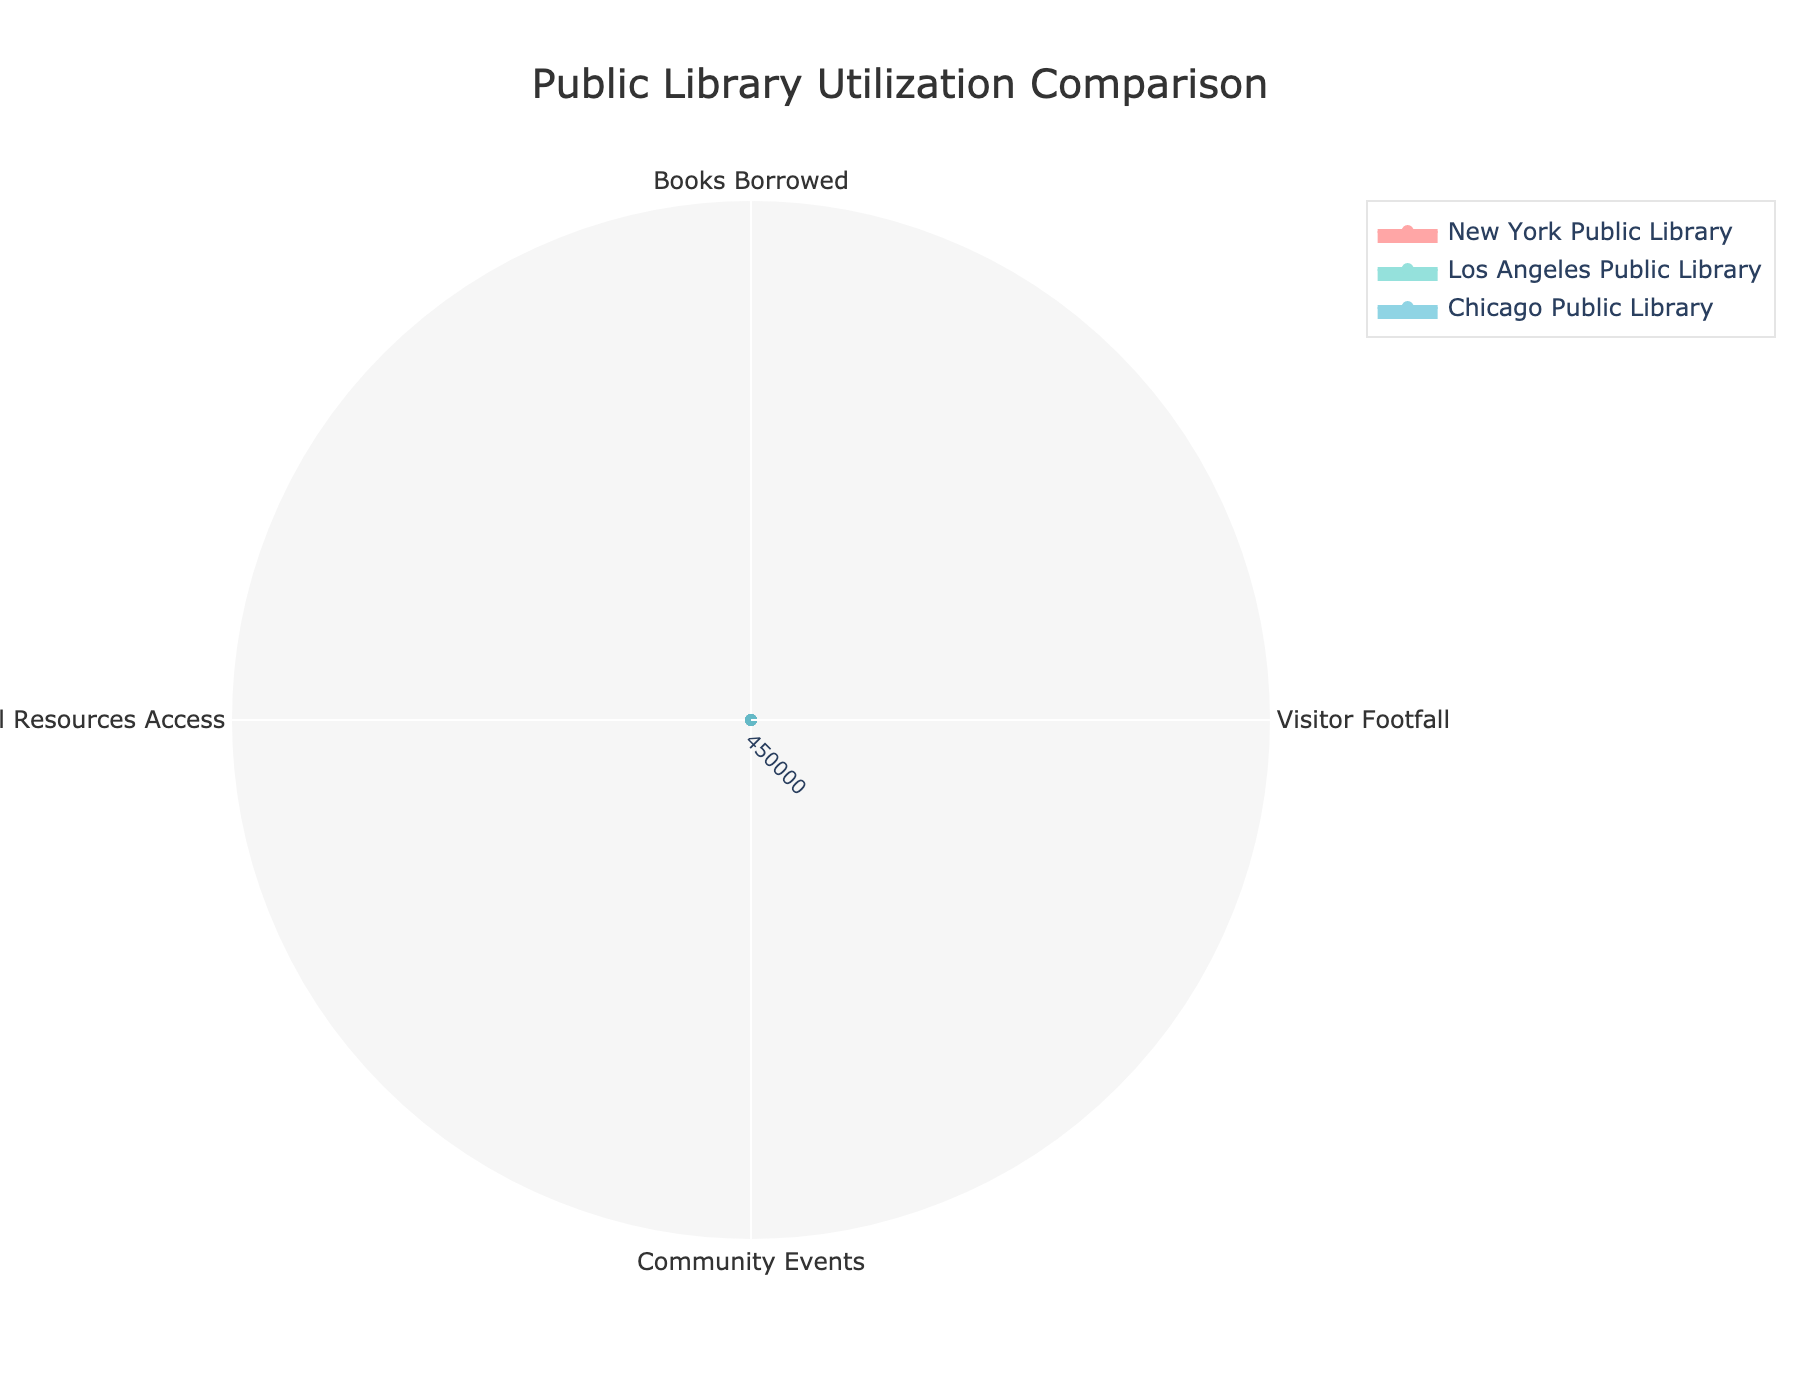What's the title of the figure? The title is usually located at the top of the figure. By directly looking at the top, we can see the text indicating the subject of the radar chart, which is "Public Library Utilization Comparison."
Answer: Public Library Utilization Comparison What are the categories being compared in the figure? The categories in the radar chart represent different metrics for library utilization, which include books borrowed, visitor footfall, community events, and digital resources access.
Answer: Books Borrowed, Visitor Footfall, Community Events, Digital Resources Access Which library has the highest visitor footfall? By examining the radar chart, for the "Visitor Footfall" category, we can compare the lengths of the corresponding section between different libraries. The library with the longest section in this category has the highest visitor footfall. It's New York Public Library.
Answer: New York Public Library How many data points are present for each library? The figure represents the utilization data of each library across four different categories, namely books borrowed, visitor footfall, community events, and digital resources access. So, there are four data points for each library.
Answer: 4 Which category shows the smallest usage for the Chicago Public Library? To find the smallest usage, observe the radar chart sections corresponding to Chicago Public Library across all four categories and identify the shortest section. This is in "Community Events."
Answer: Community Events 